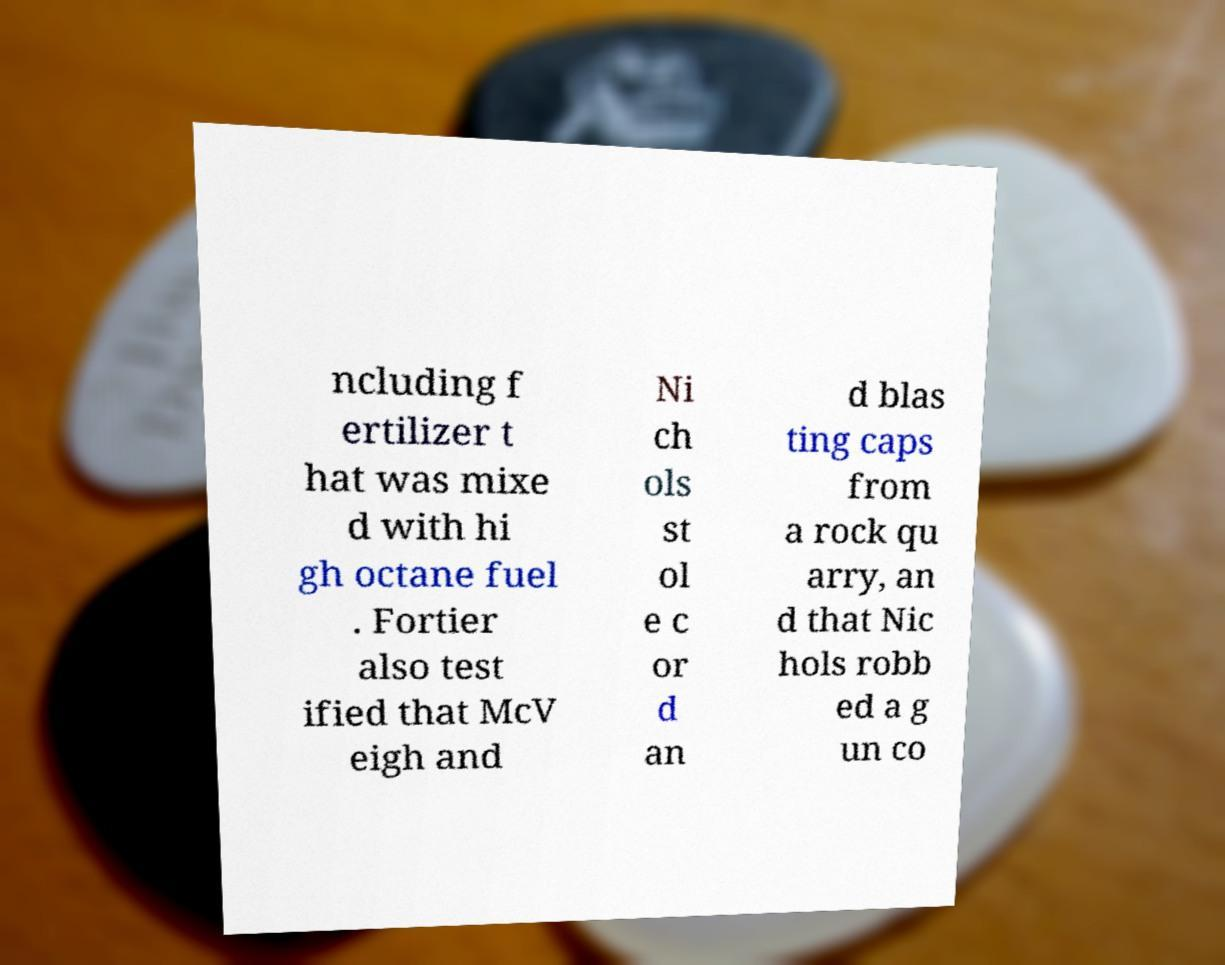I need the written content from this picture converted into text. Can you do that? ncluding f ertilizer t hat was mixe d with hi gh octane fuel . Fortier also test ified that McV eigh and Ni ch ols st ol e c or d an d blas ting caps from a rock qu arry, an d that Nic hols robb ed a g un co 